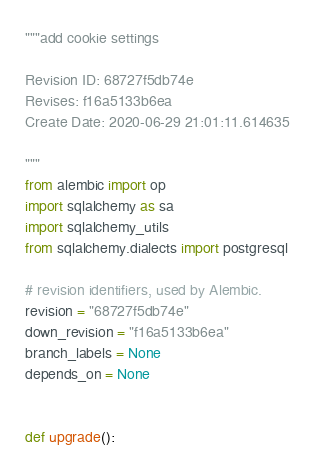<code> <loc_0><loc_0><loc_500><loc_500><_Python_>"""add cookie settings

Revision ID: 68727f5db74e
Revises: f16a5133b6ea
Create Date: 2020-06-29 21:01:11.614635

"""
from alembic import op
import sqlalchemy as sa
import sqlalchemy_utils
from sqlalchemy.dialects import postgresql

# revision identifiers, used by Alembic.
revision = "68727f5db74e"
down_revision = "f16a5133b6ea"
branch_labels = None
depends_on = None


def upgrade():</code> 